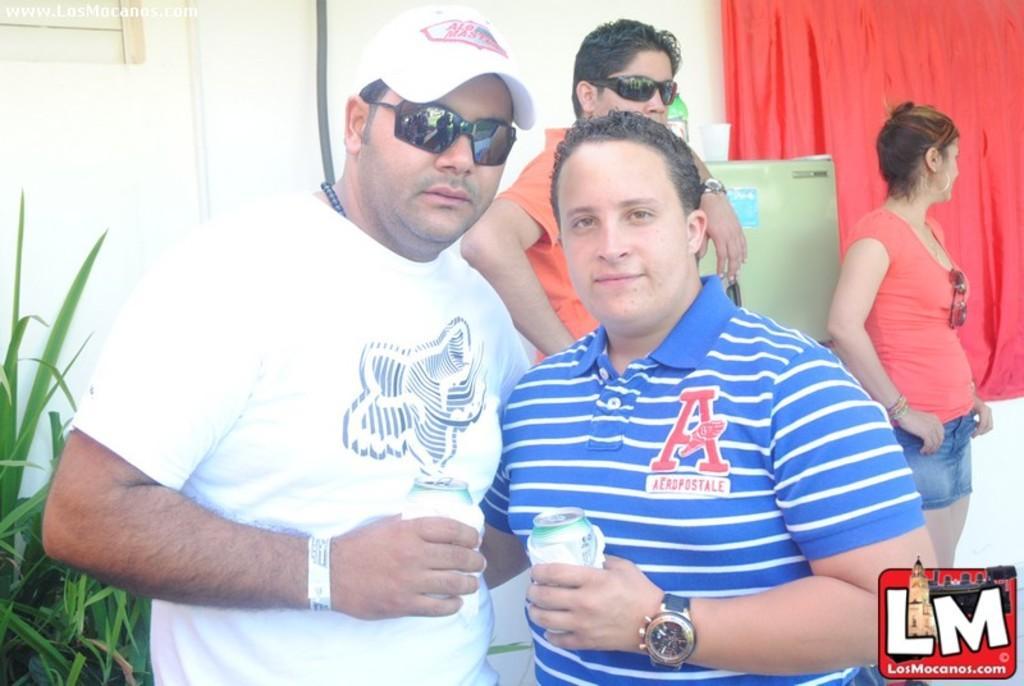Please provide a concise description of this image. In this picture I can observe two men. Both of them are wearing T shirts and holding things in their hands. One of them is wearing spectacles and a cap on his head. In the background I can observe a woman on the right side. There is a curtain which is in red color behind the woman. In the background I can observe a wall. 